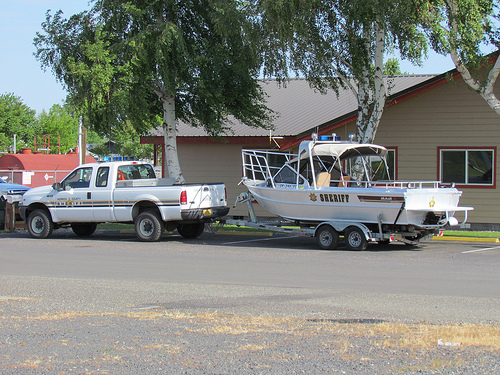<image>
Is there a boat in front of the truck? No. The boat is not in front of the truck. The spatial positioning shows a different relationship between these objects. 